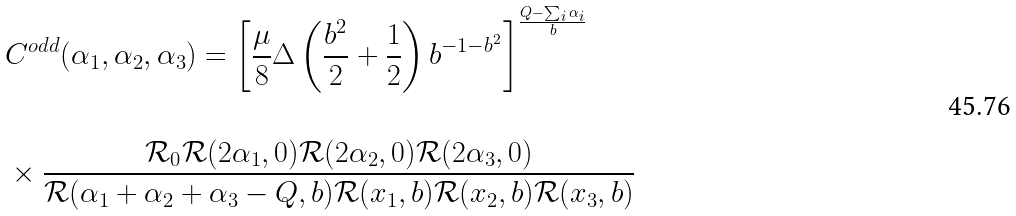<formula> <loc_0><loc_0><loc_500><loc_500>& C ^ { o d d } ( \alpha _ { 1 } , \alpha _ { 2 } , \alpha _ { 3 } ) = \left [ \frac { \mu } { 8 } \Delta \left ( \frac { b ^ { 2 } } { 2 } + \frac { 1 } { 2 } \right ) b ^ { - 1 - b ^ { 2 } } \right ] ^ { \frac { Q - \sum _ { i } \alpha _ { i } } { b } } \\ & \\ & \times \frac { \mathcal { R } _ { 0 } \mathcal { R } ( 2 \alpha _ { 1 } , 0 ) \mathcal { R } ( 2 \alpha _ { 2 } , 0 ) \mathcal { R } ( 2 \alpha _ { 3 } , 0 ) } { \mathcal { R } ( \alpha _ { 1 } + \alpha _ { 2 } + \alpha _ { 3 } - Q , b ) \mathcal { R } ( x _ { 1 } , b ) \mathcal { R } ( x _ { 2 } , b ) \mathcal { R } ( x _ { 3 } , b ) }</formula> 